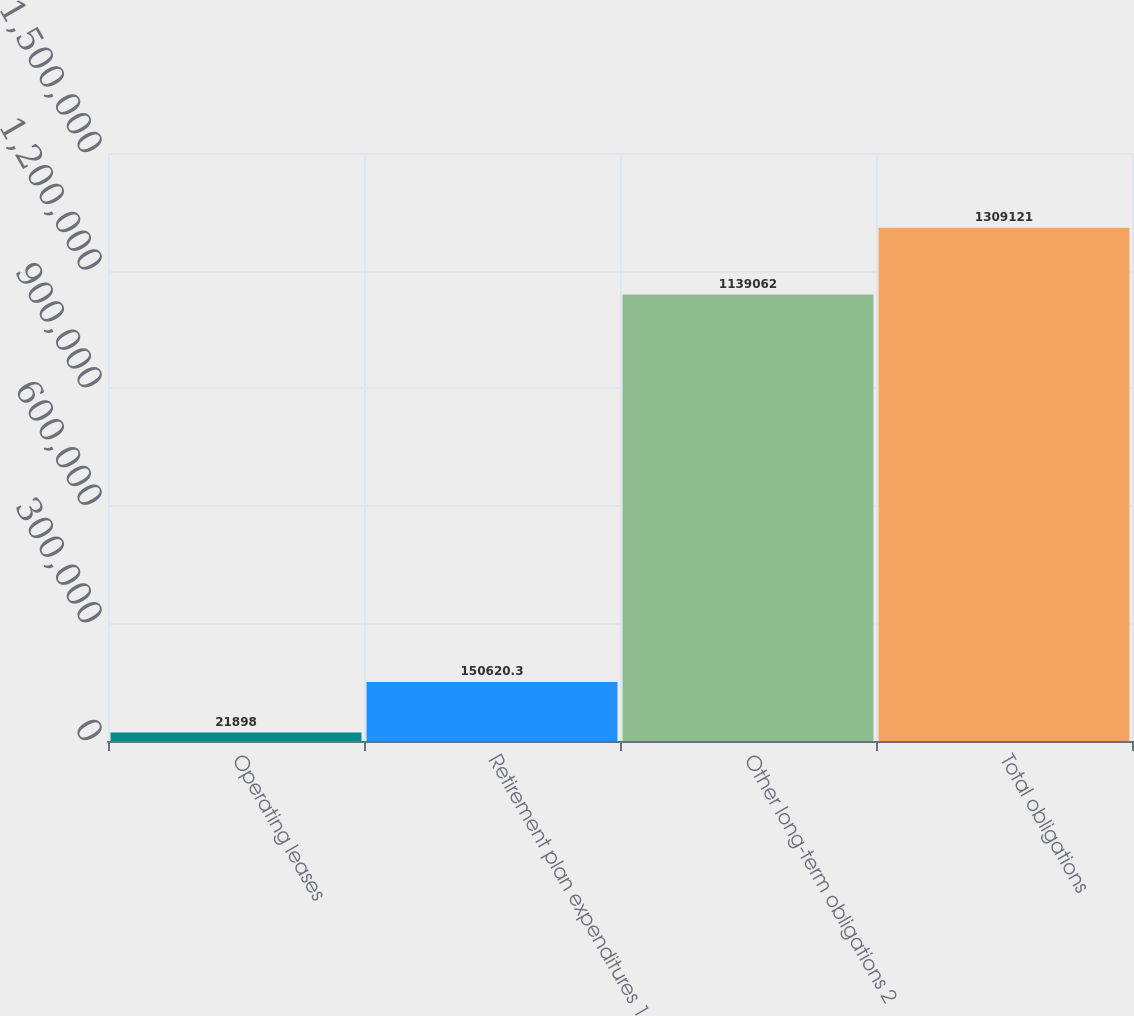Convert chart to OTSL. <chart><loc_0><loc_0><loc_500><loc_500><bar_chart><fcel>Operating leases<fcel>Retirement plan expenditures 1<fcel>Other long-term obligations 2<fcel>Total obligations<nl><fcel>21898<fcel>150620<fcel>1.13906e+06<fcel>1.30912e+06<nl></chart> 